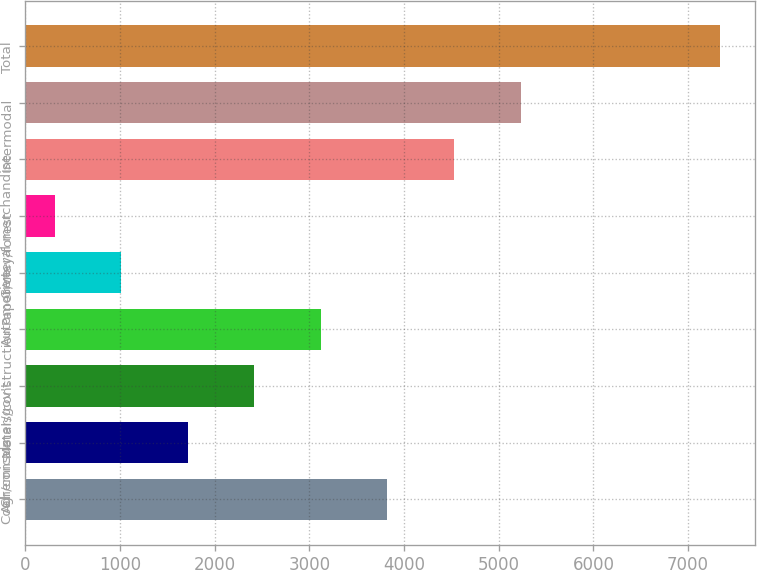Convert chart. <chart><loc_0><loc_0><loc_500><loc_500><bar_chart><fcel>Coal<fcel>Chemicals<fcel>Agr/consumer/gov't<fcel>Metals/construction<fcel>Automotive<fcel>Paper/clay/forest<fcel>General merchandise<fcel>Intermodal<fcel>Total<nl><fcel>3825.15<fcel>1715.7<fcel>2418.85<fcel>3122<fcel>1012.55<fcel>309.4<fcel>4528.3<fcel>5231.45<fcel>7340.9<nl></chart> 